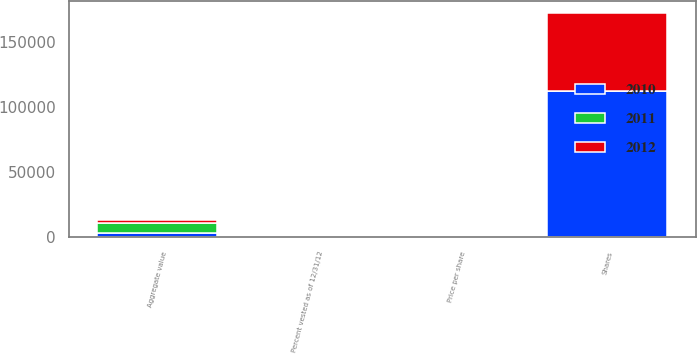Convert chart to OTSL. <chart><loc_0><loc_0><loc_500><loc_500><stacked_bar_chart><ecel><fcel>Shares<fcel>Price per share<fcel>Aggregate value<fcel>Percent vested as of 12/31/12<nl><fcel>2012<fcel>60000<fcel>46.12<fcel>2767<fcel>0<nl><fcel>2011<fcel>46.12<fcel>44.39<fcel>7424<fcel>20<nl><fcel>2010<fcel>112500<fcel>30.87<fcel>3473<fcel>40<nl></chart> 